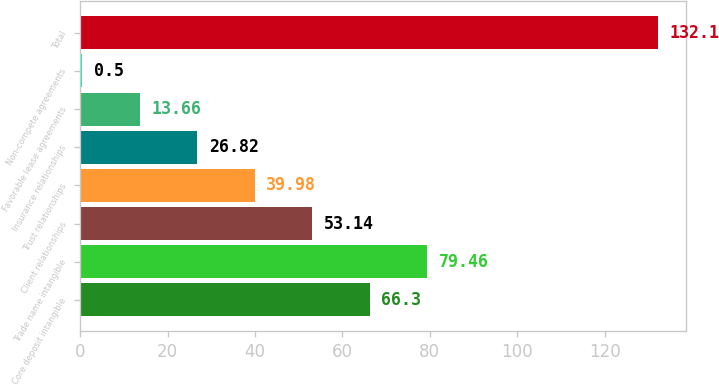Convert chart to OTSL. <chart><loc_0><loc_0><loc_500><loc_500><bar_chart><fcel>Core deposit intangible<fcel>Trade name intangible<fcel>Client relationships<fcel>Trust relationships<fcel>Insurance relationships<fcel>Favorable lease agreements<fcel>Non-compete agreements<fcel>Total<nl><fcel>66.3<fcel>79.46<fcel>53.14<fcel>39.98<fcel>26.82<fcel>13.66<fcel>0.5<fcel>132.1<nl></chart> 